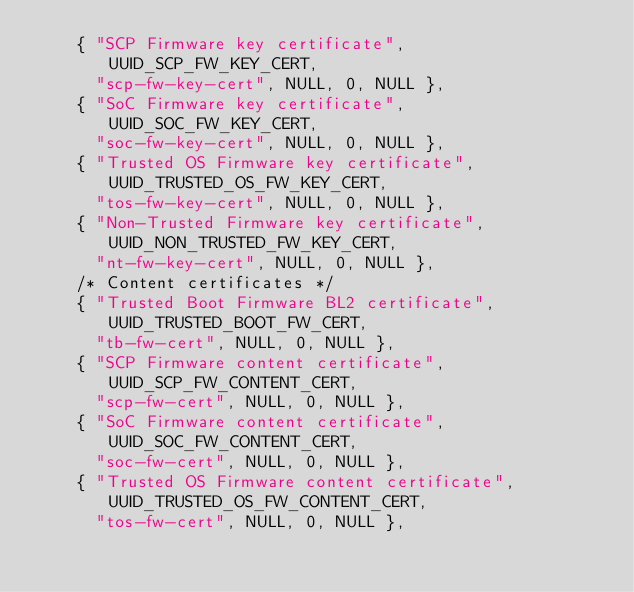<code> <loc_0><loc_0><loc_500><loc_500><_C_>	{ "SCP Firmware key certificate", UUID_SCP_FW_KEY_CERT,
	  "scp-fw-key-cert", NULL, 0, NULL },
	{ "SoC Firmware key certificate", UUID_SOC_FW_KEY_CERT,
	  "soc-fw-key-cert", NULL, 0, NULL },
	{ "Trusted OS Firmware key certificate", UUID_TRUSTED_OS_FW_KEY_CERT,
	  "tos-fw-key-cert", NULL, 0, NULL },
	{ "Non-Trusted Firmware key certificate", UUID_NON_TRUSTED_FW_KEY_CERT,
	  "nt-fw-key-cert", NULL, 0, NULL },
	/* Content certificates */
	{ "Trusted Boot Firmware BL2 certificate", UUID_TRUSTED_BOOT_FW_CERT,
	  "tb-fw-cert", NULL, 0, NULL },
	{ "SCP Firmware content certificate", UUID_SCP_FW_CONTENT_CERT,
	  "scp-fw-cert", NULL, 0, NULL },
	{ "SoC Firmware content certificate", UUID_SOC_FW_CONTENT_CERT,
	  "soc-fw-cert", NULL, 0, NULL },
	{ "Trusted OS Firmware content certificate", UUID_TRUSTED_OS_FW_CONTENT_CERT,
	  "tos-fw-cert", NULL, 0, NULL },</code> 